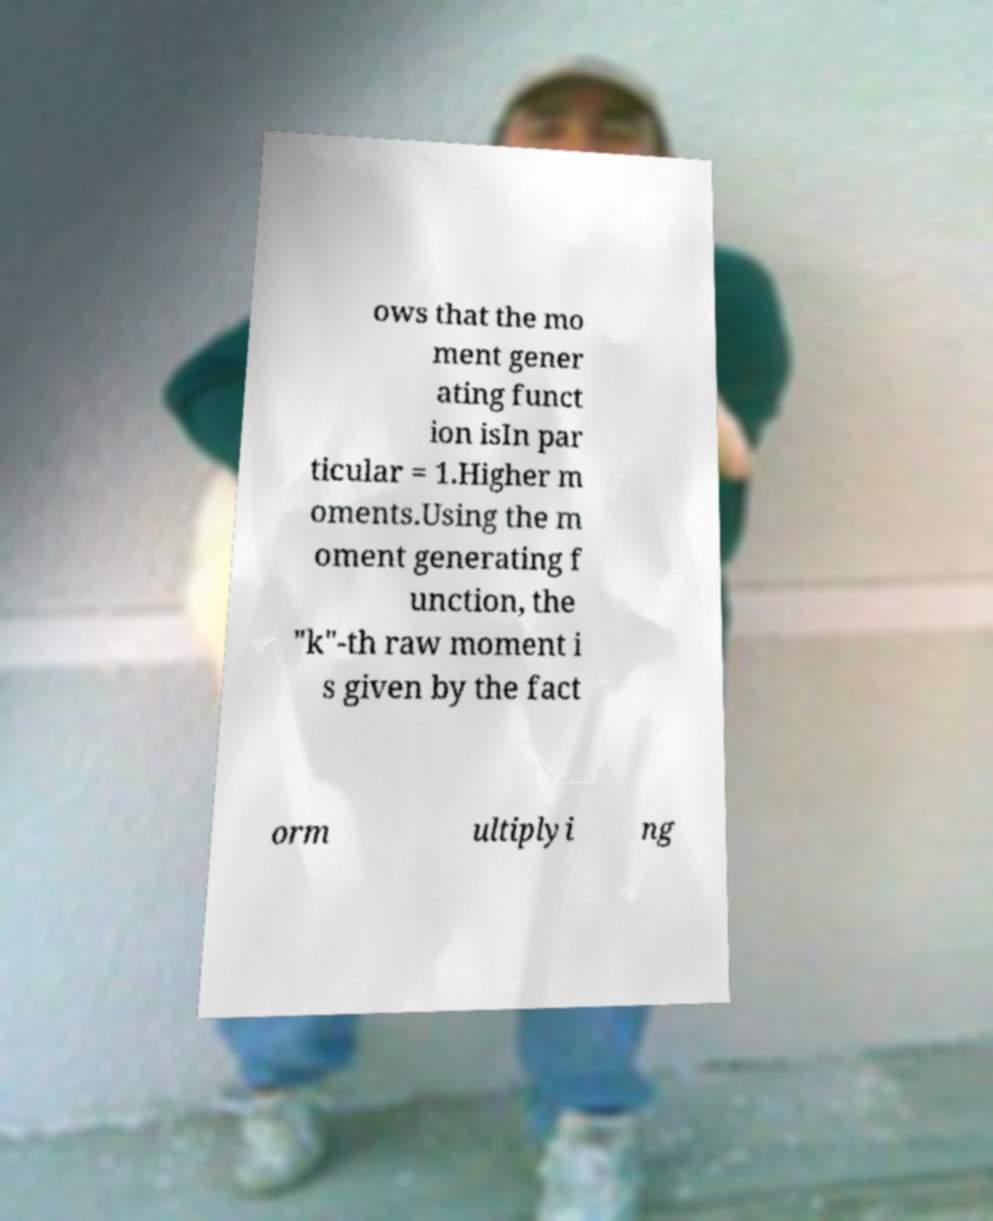Could you assist in decoding the text presented in this image and type it out clearly? ows that the mo ment gener ating funct ion isIn par ticular = 1.Higher m oments.Using the m oment generating f unction, the "k"-th raw moment i s given by the fact orm ultiplyi ng 